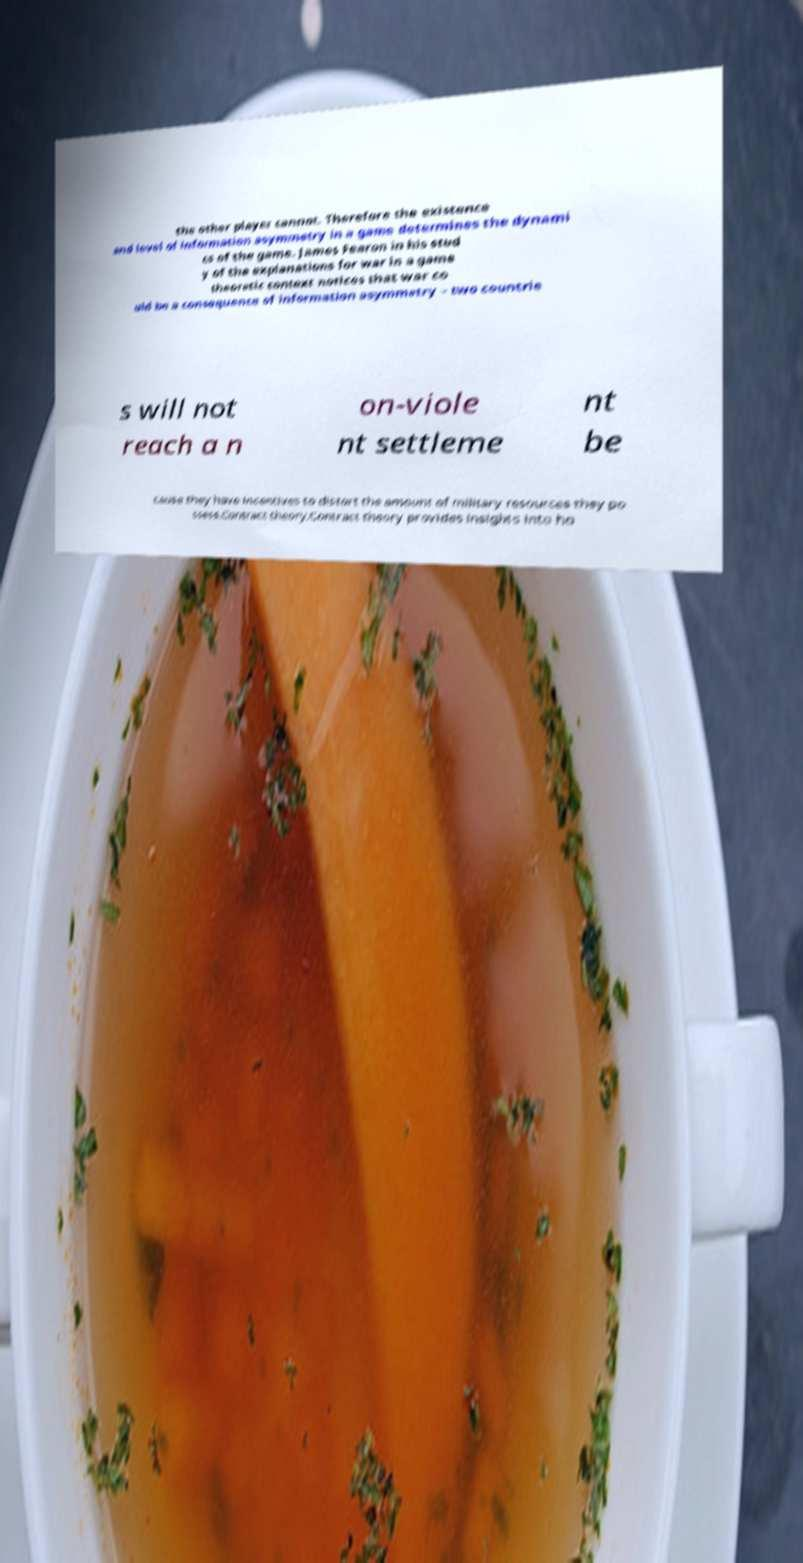Please identify and transcribe the text found in this image. the other player cannot. Therefore the existence and level of information asymmetry in a game determines the dynami cs of the game. James Fearon in his stud y of the explanations for war in a game theoretic context notices that war co uld be a consequence of information asymmetry – two countrie s will not reach a n on-viole nt settleme nt be cause they have incentives to distort the amount of military resources they po ssess.Contract theory.Contract theory provides insights into ho 